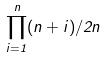<formula> <loc_0><loc_0><loc_500><loc_500>\prod _ { i = 1 } ^ { n } ( n + i ) / 2 n</formula> 